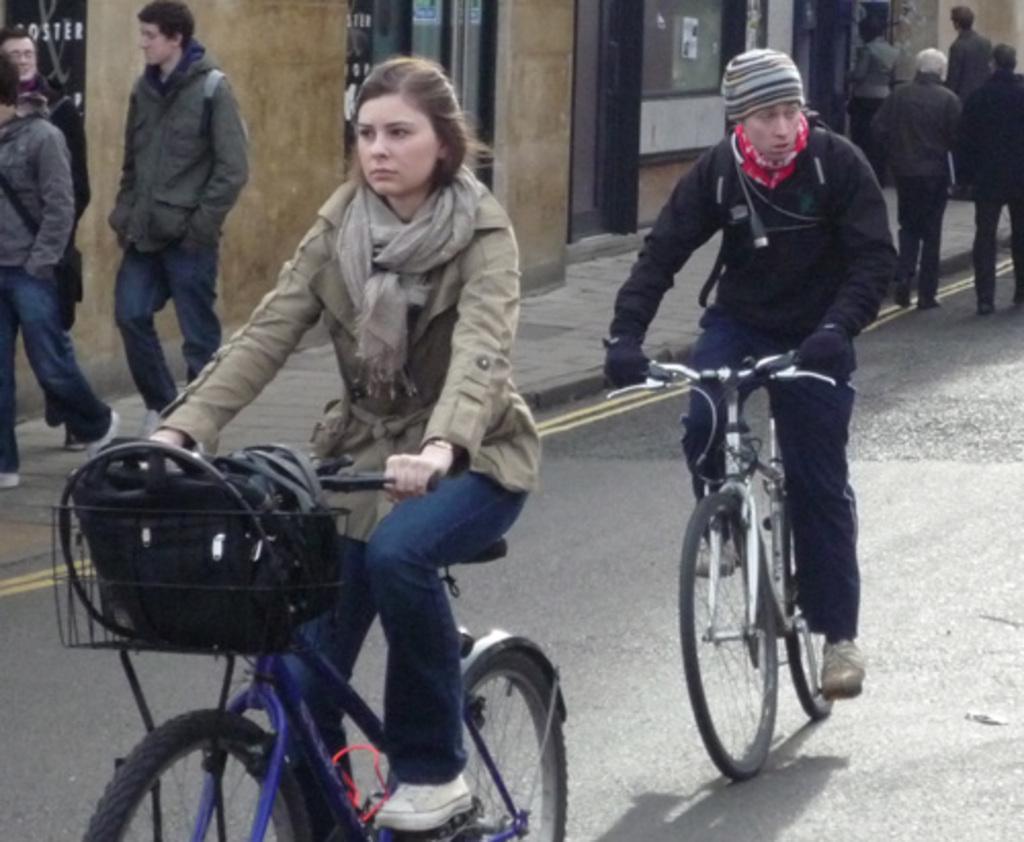Can you describe this image briefly? In this image, we can see people wearing coats and some are wearing bags and we can see people riding on the bicycles wearing coats and one of them is wearing a scarf and the other is wearing a cap and gloves and there are some bags in the basket and there is a wall. At the bottom, there is a sidewalk and a road. 